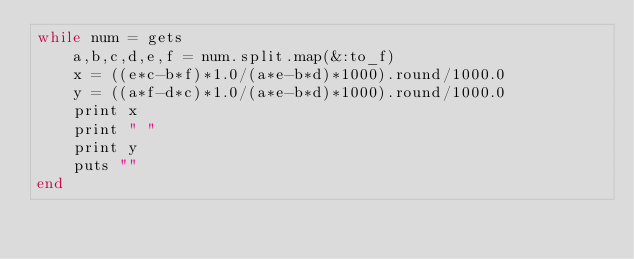Convert code to text. <code><loc_0><loc_0><loc_500><loc_500><_Ruby_>while num = gets
	a,b,c,d,e,f = num.split.map(&:to_f)
	x = ((e*c-b*f)*1.0/(a*e-b*d)*1000).round/1000.0
	y = ((a*f-d*c)*1.0/(a*e-b*d)*1000).round/1000.0
	print x
	print " "
	print y
	puts ""
end</code> 